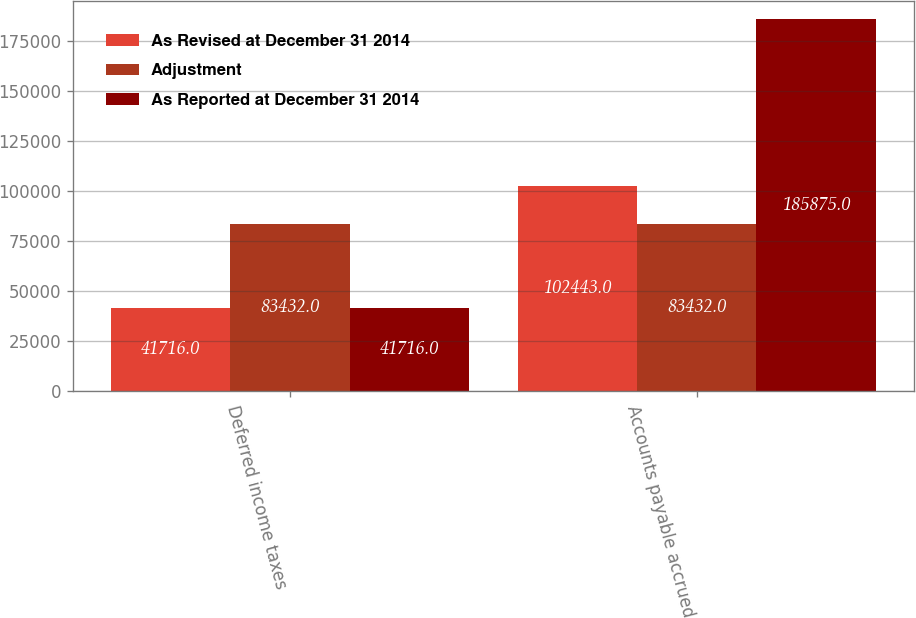<chart> <loc_0><loc_0><loc_500><loc_500><stacked_bar_chart><ecel><fcel>Deferred income taxes<fcel>Accounts payable accrued<nl><fcel>As Revised at December 31 2014<fcel>41716<fcel>102443<nl><fcel>Adjustment<fcel>83432<fcel>83432<nl><fcel>As Reported at December 31 2014<fcel>41716<fcel>185875<nl></chart> 